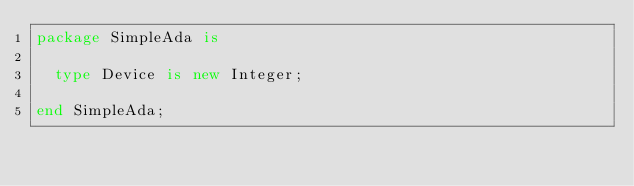<code> <loc_0><loc_0><loc_500><loc_500><_Ada_>package SimpleAda is

  type Device is new Integer; 

end SimpleAda;
</code> 